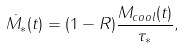Convert formula to latex. <formula><loc_0><loc_0><loc_500><loc_500>\dot { M _ { * } } ( t ) = ( 1 - R ) \frac { M _ { c o o l } ( t ) } { \tau _ { * } } ,</formula> 